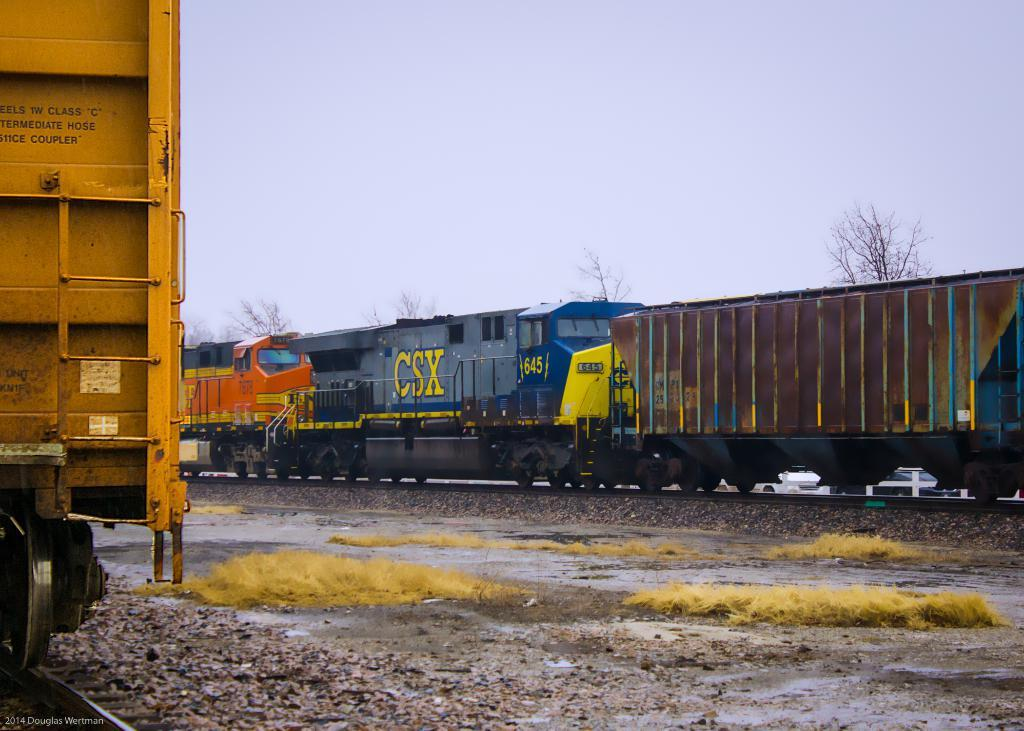What type of vehicle is in the left corner of the image? There is a vehicle in the left corner of the image, but the specific type is not mentioned in the facts. What is located at the bottom of the image? There is ground at the bottom of the image. What other mode of transportation can be seen in the image? There is a train in the image. What can be seen in the background of the image? There are trees in the background of the image. What is visible at the top of the image? The sky is visible at the top of the image. What type of coil is being used by the governor in the image? There is no governor or coil present in the image. Who is the partner of the person driving the vehicle in the image? There is no information about a partner or a person driving the vehicle in the image. 